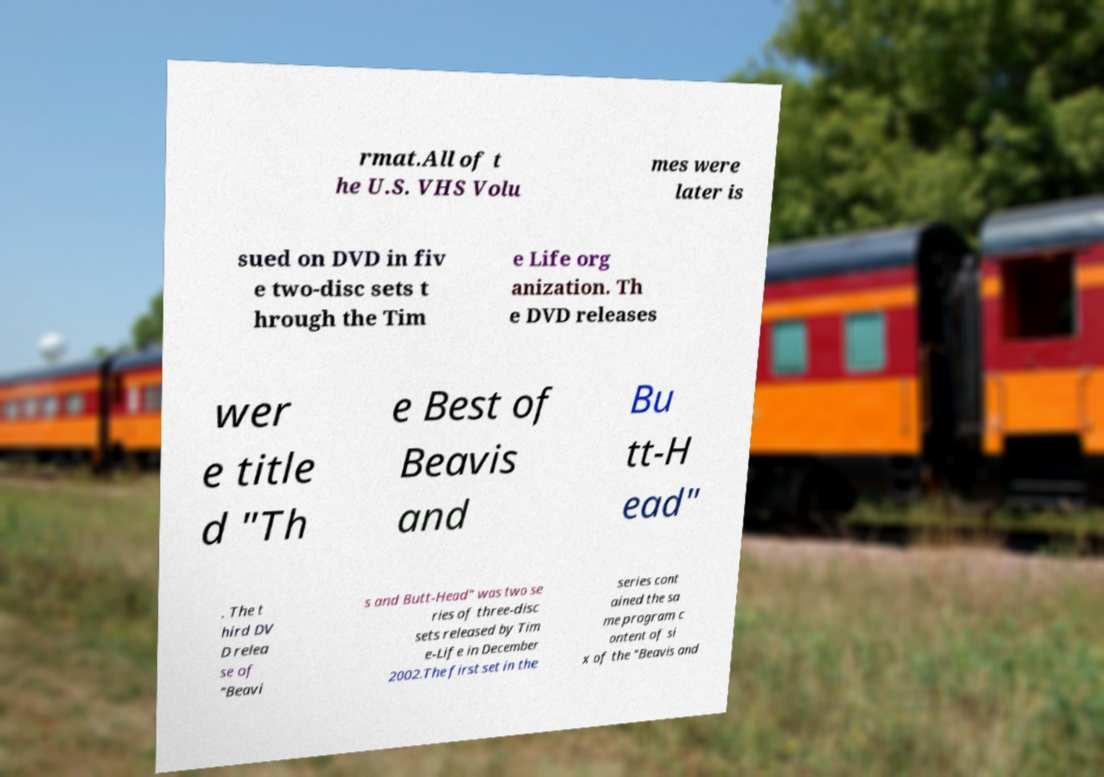What messages or text are displayed in this image? I need them in a readable, typed format. rmat.All of t he U.S. VHS Volu mes were later is sued on DVD in fiv e two-disc sets t hrough the Tim e Life org anization. Th e DVD releases wer e title d "Th e Best of Beavis and Bu tt-H ead" . The t hird DV D relea se of "Beavi s and Butt-Head" was two se ries of three-disc sets released by Tim e-Life in December 2002.The first set in the series cont ained the sa me program c ontent of si x of the "Beavis and 